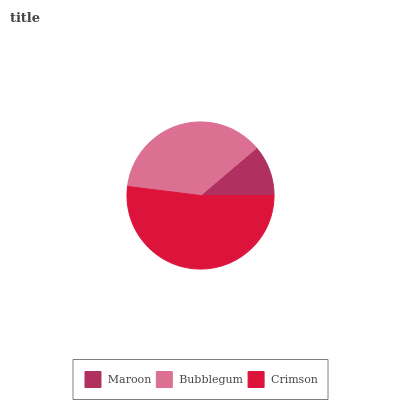Is Maroon the minimum?
Answer yes or no. Yes. Is Crimson the maximum?
Answer yes or no. Yes. Is Bubblegum the minimum?
Answer yes or no. No. Is Bubblegum the maximum?
Answer yes or no. No. Is Bubblegum greater than Maroon?
Answer yes or no. Yes. Is Maroon less than Bubblegum?
Answer yes or no. Yes. Is Maroon greater than Bubblegum?
Answer yes or no. No. Is Bubblegum less than Maroon?
Answer yes or no. No. Is Bubblegum the high median?
Answer yes or no. Yes. Is Bubblegum the low median?
Answer yes or no. Yes. Is Maroon the high median?
Answer yes or no. No. Is Maroon the low median?
Answer yes or no. No. 